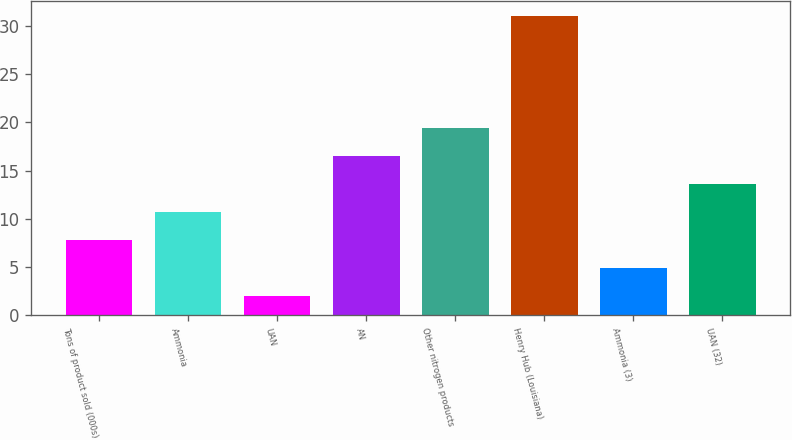Convert chart. <chart><loc_0><loc_0><loc_500><loc_500><bar_chart><fcel>Tons of product sold (000s)<fcel>Ammonia<fcel>UAN<fcel>AN<fcel>Other nitrogen products<fcel>Henry Hub (Louisiana)<fcel>Ammonia (3)<fcel>UAN (32)<nl><fcel>7.8<fcel>10.7<fcel>2<fcel>16.5<fcel>19.4<fcel>31<fcel>4.9<fcel>13.6<nl></chart> 